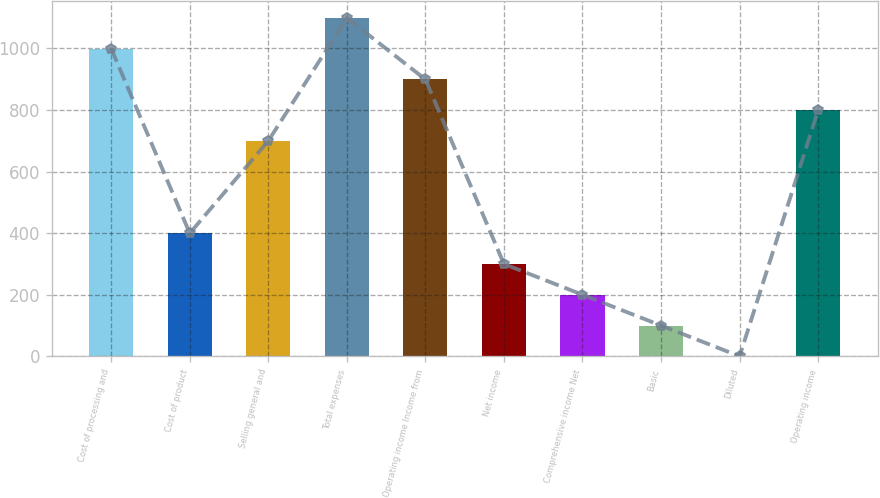<chart> <loc_0><loc_0><loc_500><loc_500><bar_chart><fcel>Cost of processing and<fcel>Cost of product<fcel>Selling general and<fcel>Total expenses<fcel>Operating income Income from<fcel>Net income<fcel>Comprehensive income Net<fcel>Basic<fcel>Diluted<fcel>Operating income<nl><fcel>999.03<fcel>400.05<fcel>699.54<fcel>1098.86<fcel>899.2<fcel>300.22<fcel>200.39<fcel>100.56<fcel>0.73<fcel>799.37<nl></chart> 